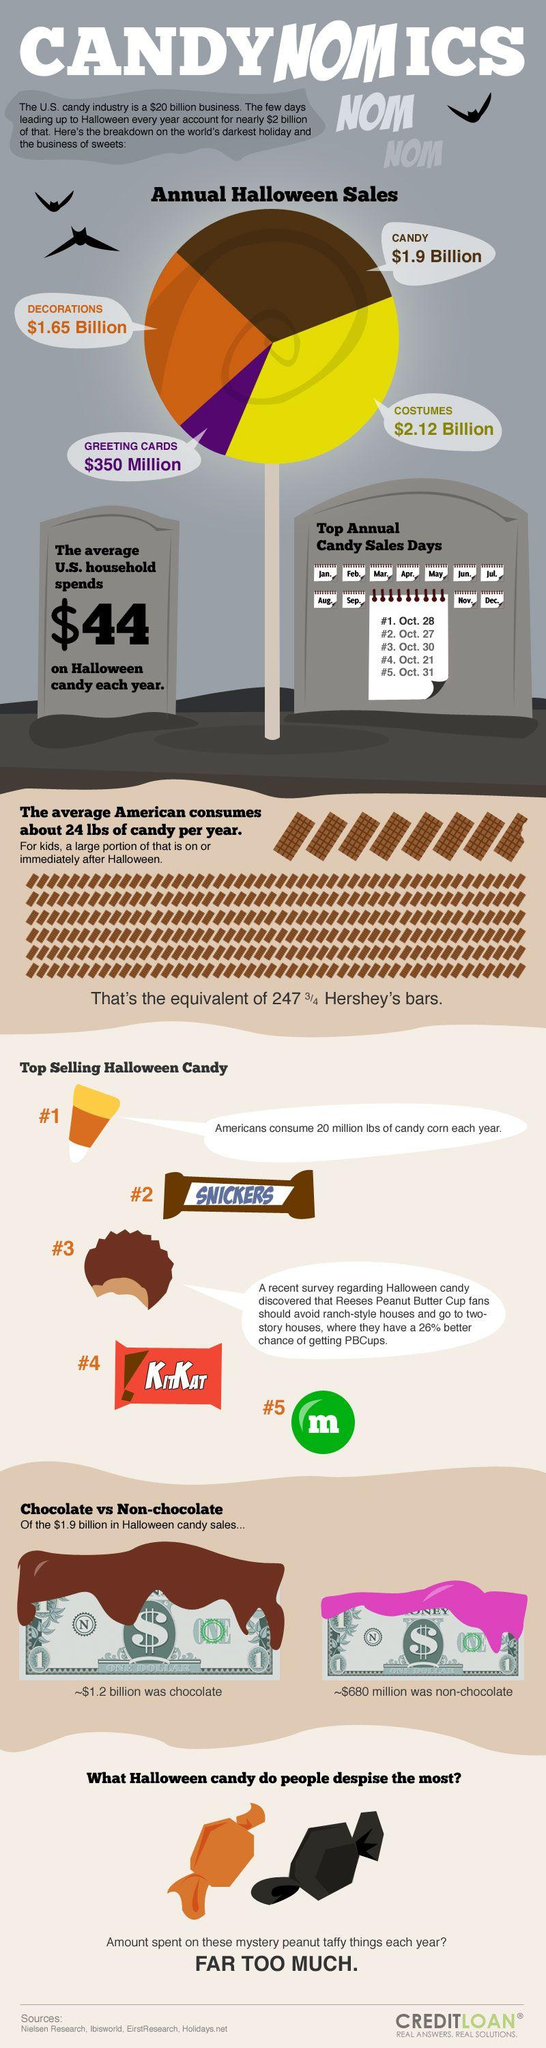Give some essential details in this illustration. The second most popular Halloween candy is Snickers. The Halloween candy shown in the info graphic with a red background wrapper color is KitKat. The item with the third highest number of sales in the Annual Halloween sales is decorations. The item with the second highest number of sales in the Annual Halloween sales is candy. 